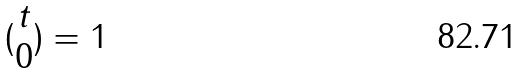Convert formula to latex. <formula><loc_0><loc_0><loc_500><loc_500>( \begin{matrix} t \\ 0 \end{matrix} ) = 1</formula> 